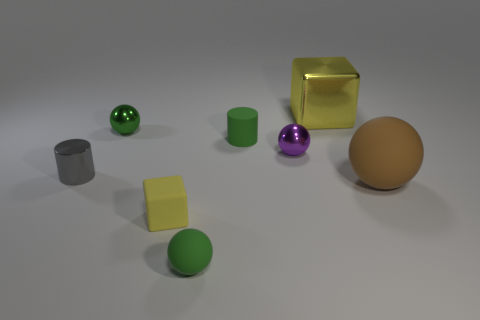Subtract all green balls. How many balls are left? 2 Add 2 big red cubes. How many objects exist? 10 Subtract all tiny green rubber spheres. How many spheres are left? 3 Subtract all brown cubes. Subtract all blue spheres. How many cubes are left? 2 Add 7 tiny purple shiny balls. How many tiny purple shiny balls exist? 8 Subtract 0 yellow cylinders. How many objects are left? 8 Subtract all cubes. How many objects are left? 6 Subtract 1 cylinders. How many cylinders are left? 1 Subtract all yellow blocks. How many gray spheres are left? 0 Subtract all tiny purple objects. Subtract all tiny gray metal cylinders. How many objects are left? 6 